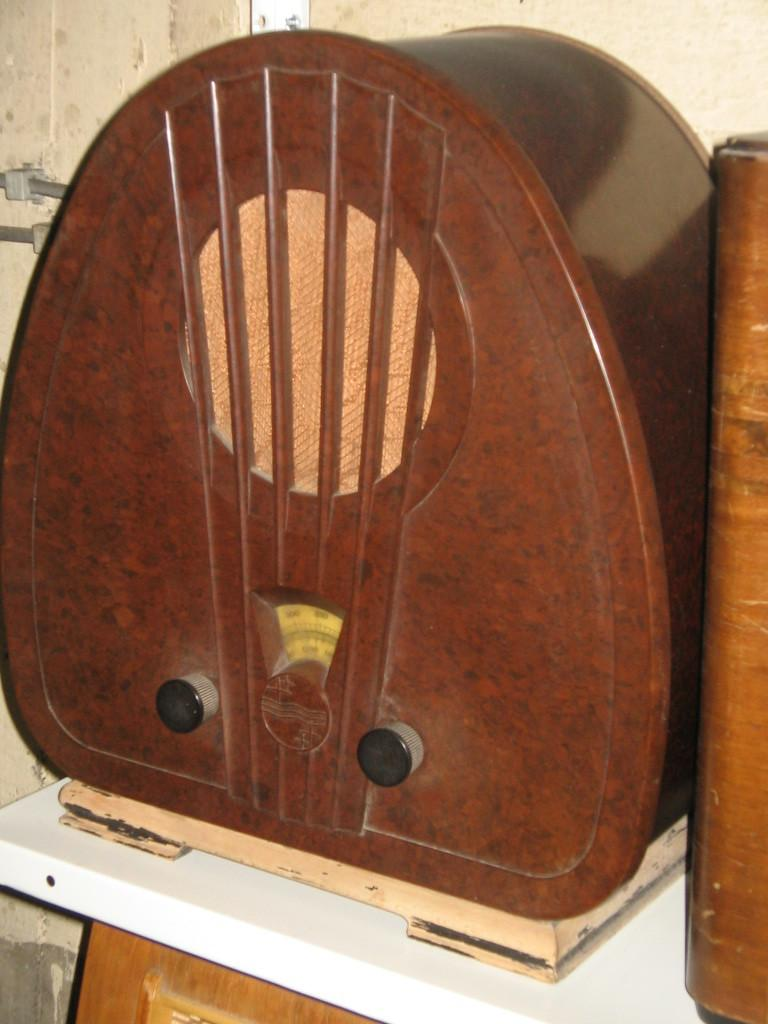What is the main object on the table in the image? There is a wooden object on the table in the image. What are some features of the wooden object? The wooden object has knobs and a scale. What can be seen behind the wooden object? There is a wall behind the wooden object. Is there a quiver hanging on the wall behind the wooden object? No, there is no quiver present in the image. Can you see any pockets on the wooden object? No, there are no pockets on the wooden object; it has knobs and a scale. 